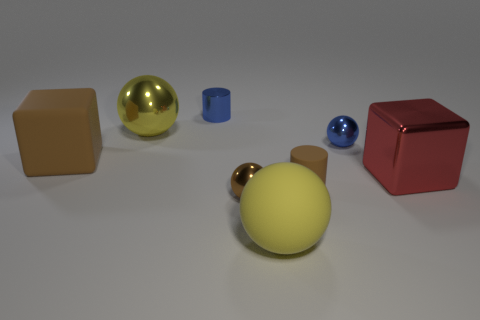There is a thing that is the same color as the metal cylinder; what is its material?
Your answer should be very brief. Metal. There is a blue object that is the same shape as the tiny brown metal thing; what material is it?
Provide a short and direct response. Metal. Does the cylinder right of the blue cylinder have the same size as the yellow shiny thing that is behind the tiny blue ball?
Offer a very short reply. No. Is there another thing made of the same material as the large red object?
Your response must be concise. Yes. What size is the shiny sphere that is the same color as the rubber ball?
Keep it short and to the point. Large. There is a big yellow sphere that is behind the large cube on the left side of the metallic cylinder; is there a tiny blue metal ball to the right of it?
Ensure brevity in your answer.  Yes. Are there any rubber spheres behind the blue sphere?
Give a very brief answer. No. What number of large rubber balls are behind the large metal thing behind the large metallic block?
Keep it short and to the point. 0. Does the brown sphere have the same size as the blue metallic object behind the tiny blue shiny sphere?
Give a very brief answer. Yes. Are there any spheres of the same color as the shiny cylinder?
Offer a terse response. Yes. 